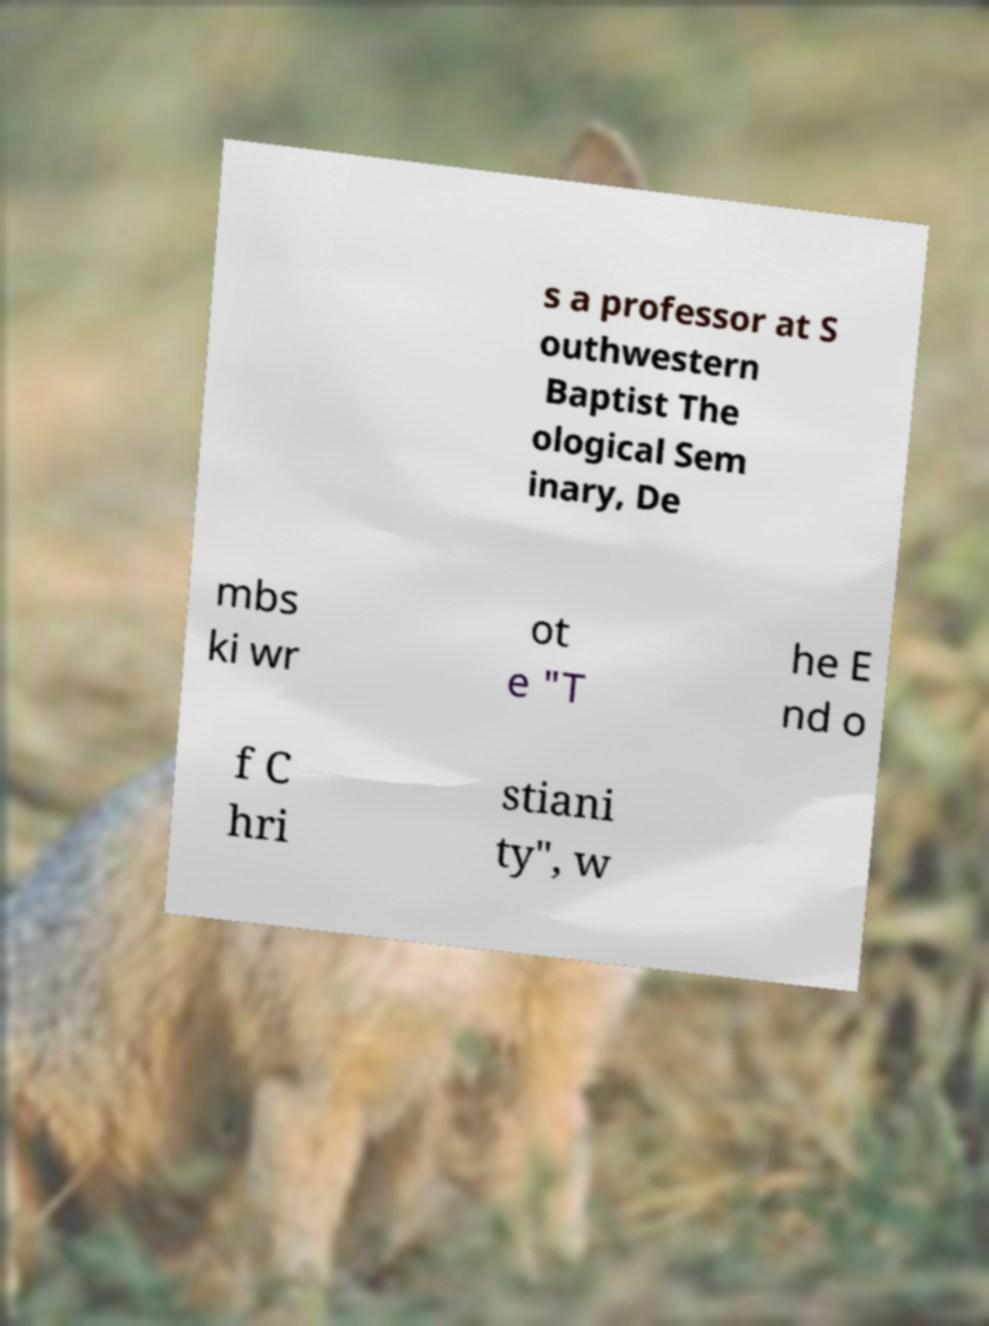Please read and relay the text visible in this image. What does it say? s a professor at S outhwestern Baptist The ological Sem inary, De mbs ki wr ot e "T he E nd o f C hri stiani ty", w 